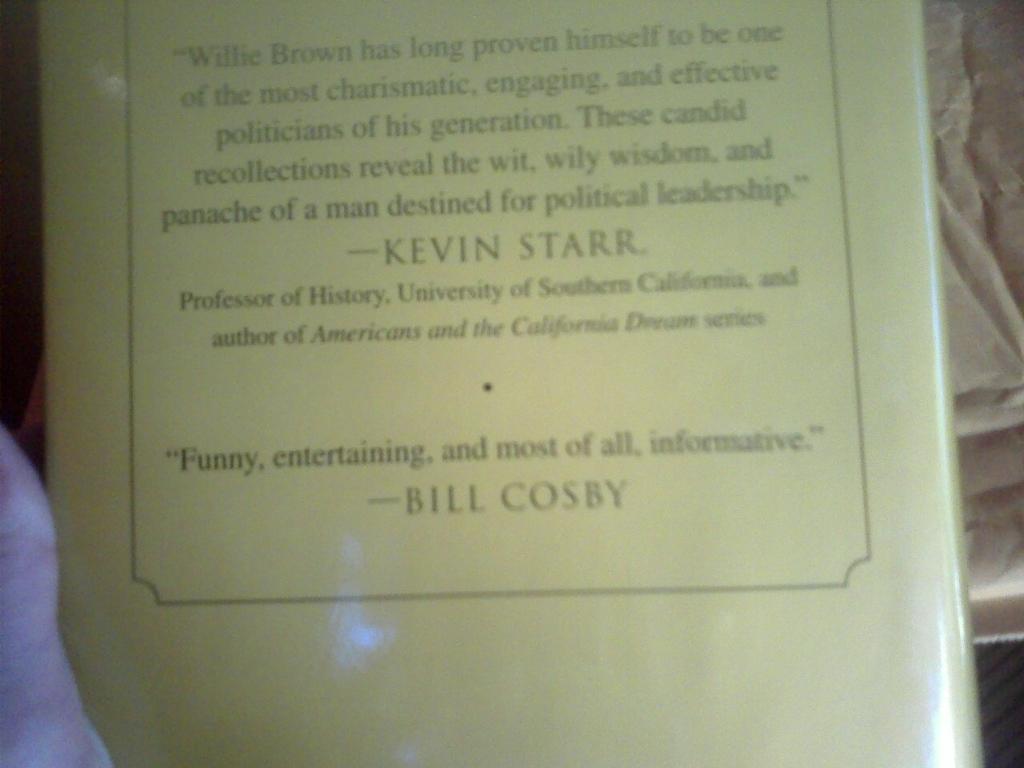What is the professor proficient in?
Keep it short and to the point. History. 